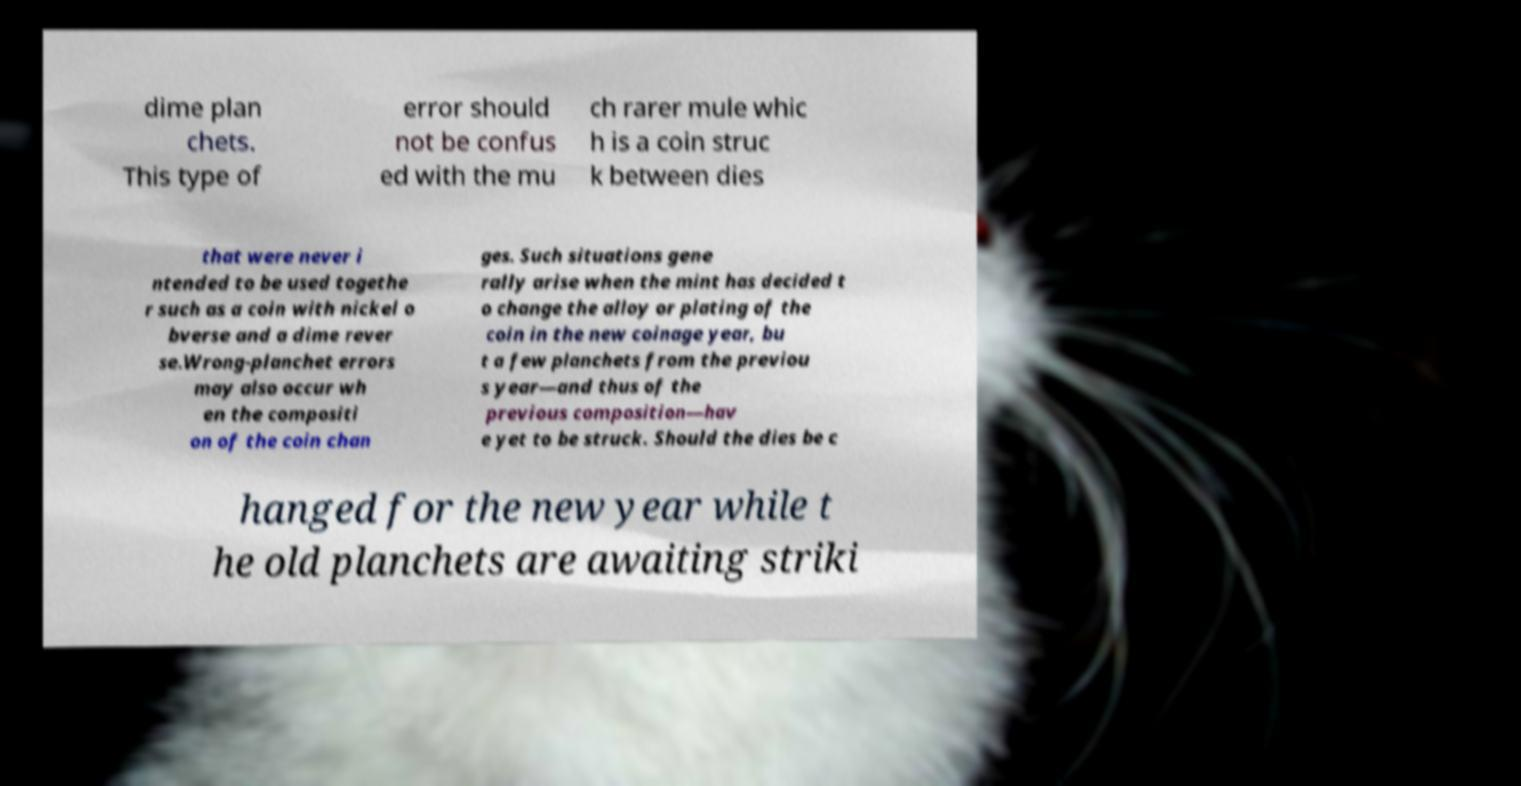Could you extract and type out the text from this image? dime plan chets. This type of error should not be confus ed with the mu ch rarer mule whic h is a coin struc k between dies that were never i ntended to be used togethe r such as a coin with nickel o bverse and a dime rever se.Wrong-planchet errors may also occur wh en the compositi on of the coin chan ges. Such situations gene rally arise when the mint has decided t o change the alloy or plating of the coin in the new coinage year, bu t a few planchets from the previou s year—and thus of the previous composition—hav e yet to be struck. Should the dies be c hanged for the new year while t he old planchets are awaiting striki 